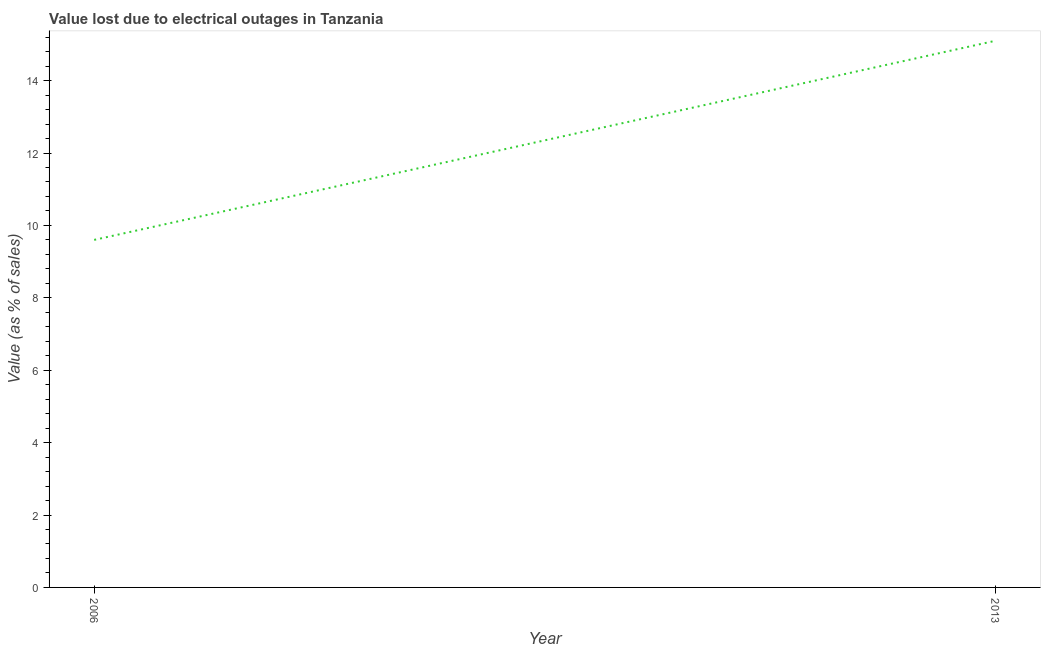Across all years, what is the minimum value lost due to electrical outages?
Offer a terse response. 9.6. In which year was the value lost due to electrical outages minimum?
Keep it short and to the point. 2006. What is the sum of the value lost due to electrical outages?
Your response must be concise. 24.7. What is the average value lost due to electrical outages per year?
Keep it short and to the point. 12.35. What is the median value lost due to electrical outages?
Your response must be concise. 12.35. Do a majority of the years between 2013 and 2006 (inclusive) have value lost due to electrical outages greater than 10.8 %?
Your answer should be compact. No. What is the ratio of the value lost due to electrical outages in 2006 to that in 2013?
Offer a terse response. 0.64. Is the value lost due to electrical outages in 2006 less than that in 2013?
Provide a succinct answer. Yes. In how many years, is the value lost due to electrical outages greater than the average value lost due to electrical outages taken over all years?
Keep it short and to the point. 1. What is the difference between two consecutive major ticks on the Y-axis?
Make the answer very short. 2. Are the values on the major ticks of Y-axis written in scientific E-notation?
Provide a short and direct response. No. What is the title of the graph?
Ensure brevity in your answer.  Value lost due to electrical outages in Tanzania. What is the label or title of the X-axis?
Your answer should be compact. Year. What is the label or title of the Y-axis?
Your answer should be compact. Value (as % of sales). What is the Value (as % of sales) in 2013?
Make the answer very short. 15.1. What is the ratio of the Value (as % of sales) in 2006 to that in 2013?
Give a very brief answer. 0.64. 